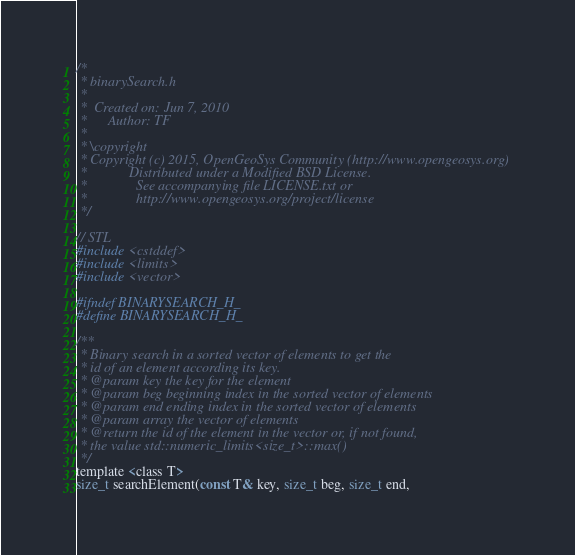Convert code to text. <code><loc_0><loc_0><loc_500><loc_500><_C_>/*
 * binarySearch.h
 *
 *  Created on: Jun 7, 2010
 *      Author: TF
 *
 * \copyright
 * Copyright (c) 2015, OpenGeoSys Community (http://www.opengeosys.org)
 *            Distributed under a Modified BSD License.
 *              See accompanying file LICENSE.txt or
 *              http://www.opengeosys.org/project/license
 */

// STL
#include <cstddef>
#include <limits>
#include <vector>

#ifndef BINARYSEARCH_H_
#define BINARYSEARCH_H_

/**
 * Binary search in a sorted vector of elements to get the
 * id of an element according its key.
 * @param key the key for the element
 * @param beg beginning index in the sorted vector of elements
 * @param end ending index in the sorted vector of elements
 * @param array the vector of elements
 * @return the id of the element in the vector or, if not found,
 * the value std::numeric_limits<size_t>::max()
 */
template <class T>
size_t searchElement(const T& key, size_t beg, size_t end,</code> 